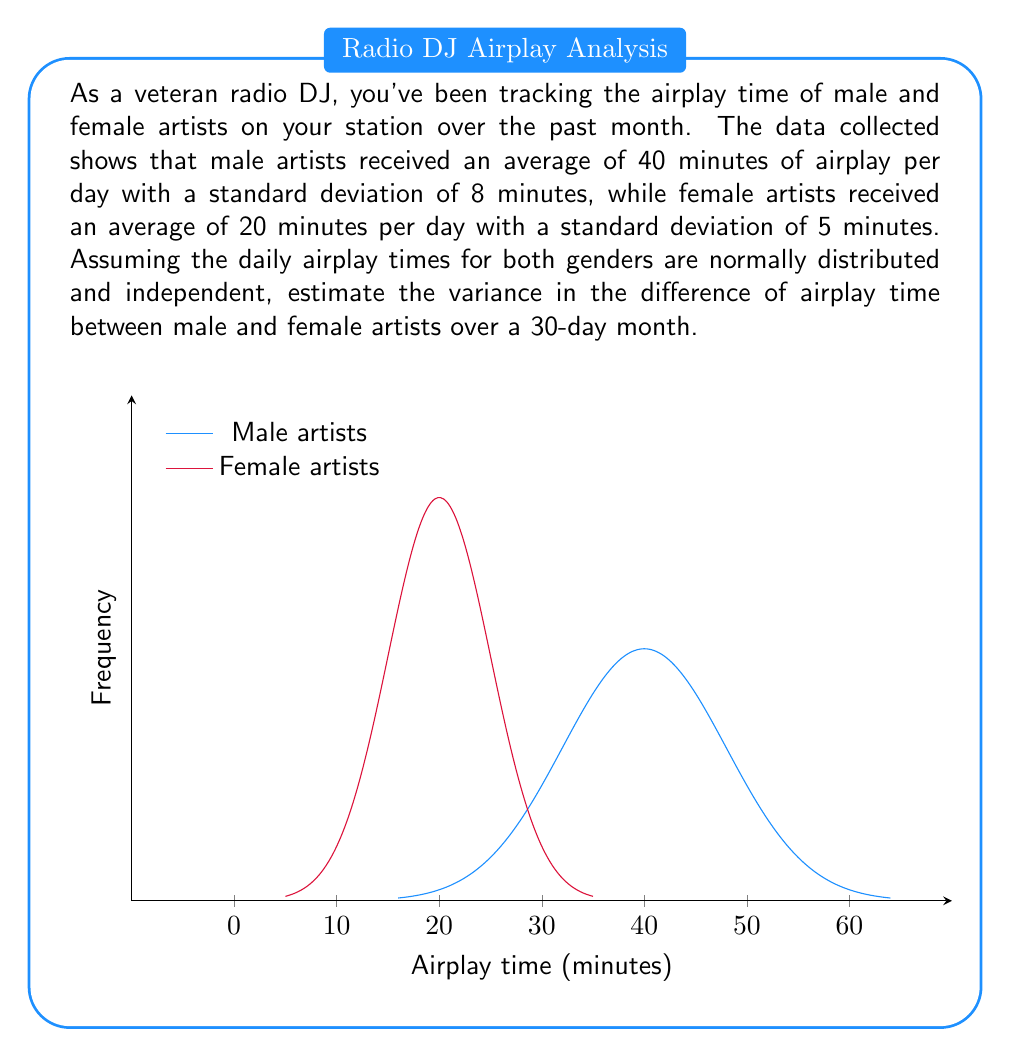Can you solve this math problem? Let's approach this step-by-step:

1) Let $M$ be the random variable for male artists' daily airplay time, and $F$ for female artists.

2) Given:
   $\mu_M = 40$ minutes, $\sigma_M = 8$ minutes
   $\mu_F = 20$ minutes, $\sigma_F = 5$ minutes

3) We're interested in the difference $D = M - F$

4) For normal distributions, the variance of a difference of independent variables is the sum of their individual variances:

   $Var(D) = Var(M) + Var(F)$

5) We know that variance is the square of standard deviation:
   
   $Var(M) = \sigma_M^2 = 8^2 = 64$
   $Var(F) = \sigma_F^2 = 5^2 = 25$

6) Therefore, the daily variance of the difference is:

   $Var(D) = 64 + 25 = 89$ (minutes²)

7) For a 30-day month, assuming independence between days, the variances add:

   $Var(D_{month}) = 30 * Var(D) = 30 * 89 = 2670$ (minutes²)
Answer: 2670 minutes² 